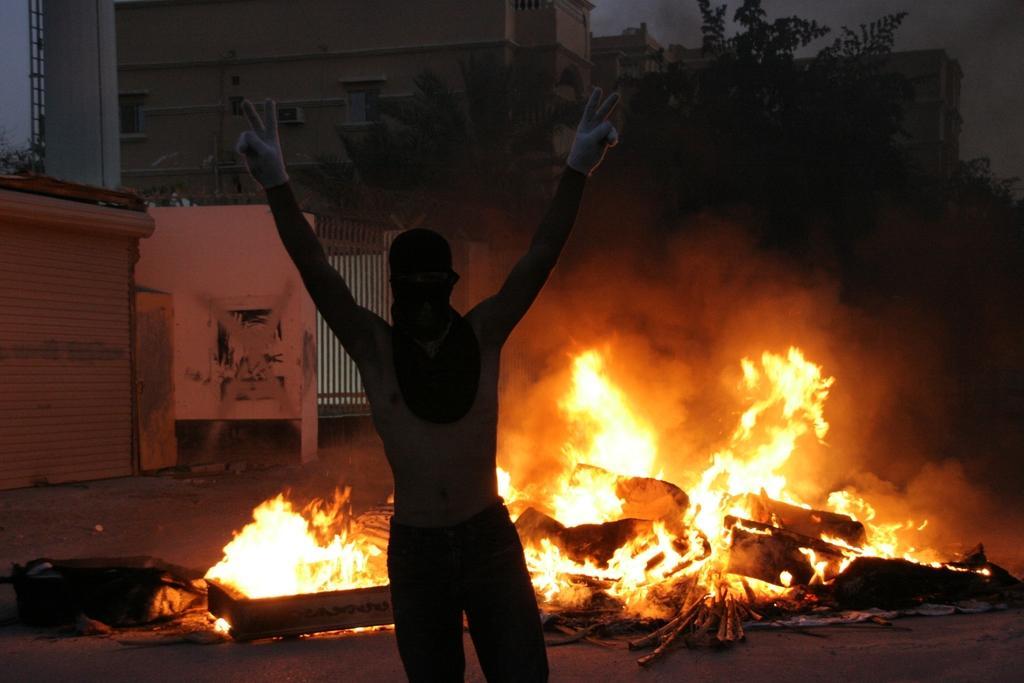Please provide a concise description of this image. In the middle of the image we can see a person, behind the person we can see fire, in the background we can see few trees and buildings. 